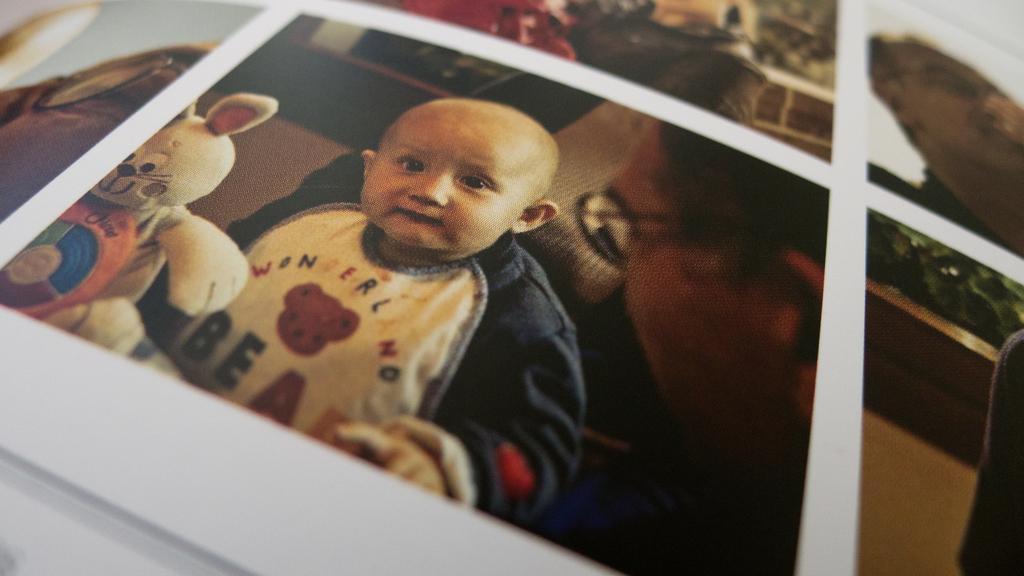How would you summarize this image in a sentence or two? In this image we can see the collage photo of some pictures and we can see a baby in the middle of the picture and we can see a toy beside the baby and there is a person's face and we can see some other things. 